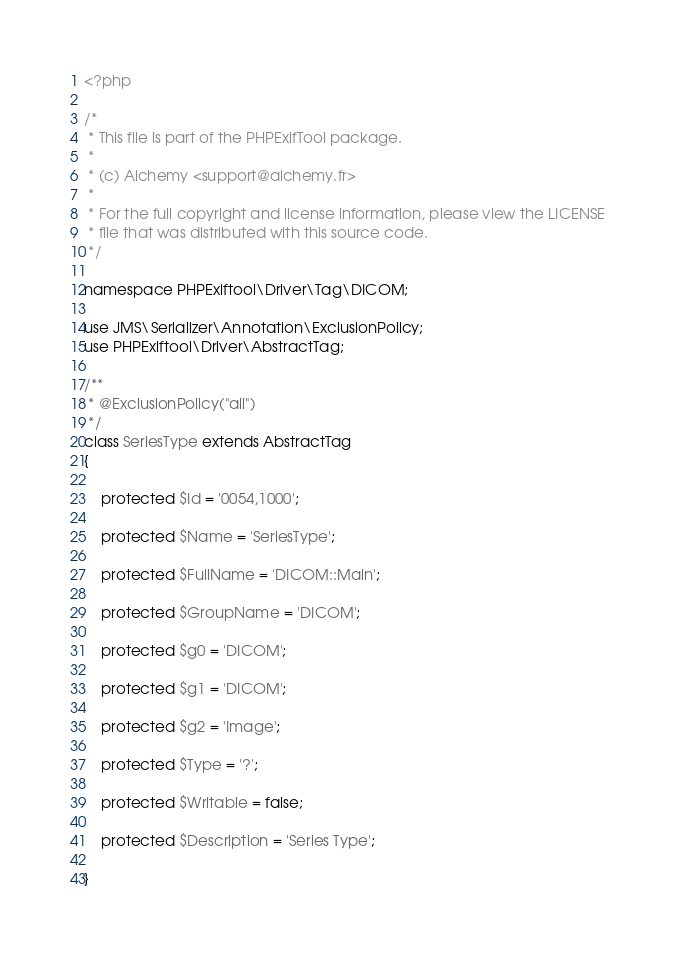<code> <loc_0><loc_0><loc_500><loc_500><_PHP_><?php

/*
 * This file is part of the PHPExifTool package.
 *
 * (c) Alchemy <support@alchemy.fr>
 *
 * For the full copyright and license information, please view the LICENSE
 * file that was distributed with this source code.
 */

namespace PHPExiftool\Driver\Tag\DICOM;

use JMS\Serializer\Annotation\ExclusionPolicy;
use PHPExiftool\Driver\AbstractTag;

/**
 * @ExclusionPolicy("all")
 */
class SeriesType extends AbstractTag
{

    protected $Id = '0054,1000';

    protected $Name = 'SeriesType';

    protected $FullName = 'DICOM::Main';

    protected $GroupName = 'DICOM';

    protected $g0 = 'DICOM';

    protected $g1 = 'DICOM';

    protected $g2 = 'Image';

    protected $Type = '?';

    protected $Writable = false;

    protected $Description = 'Series Type';

}
</code> 